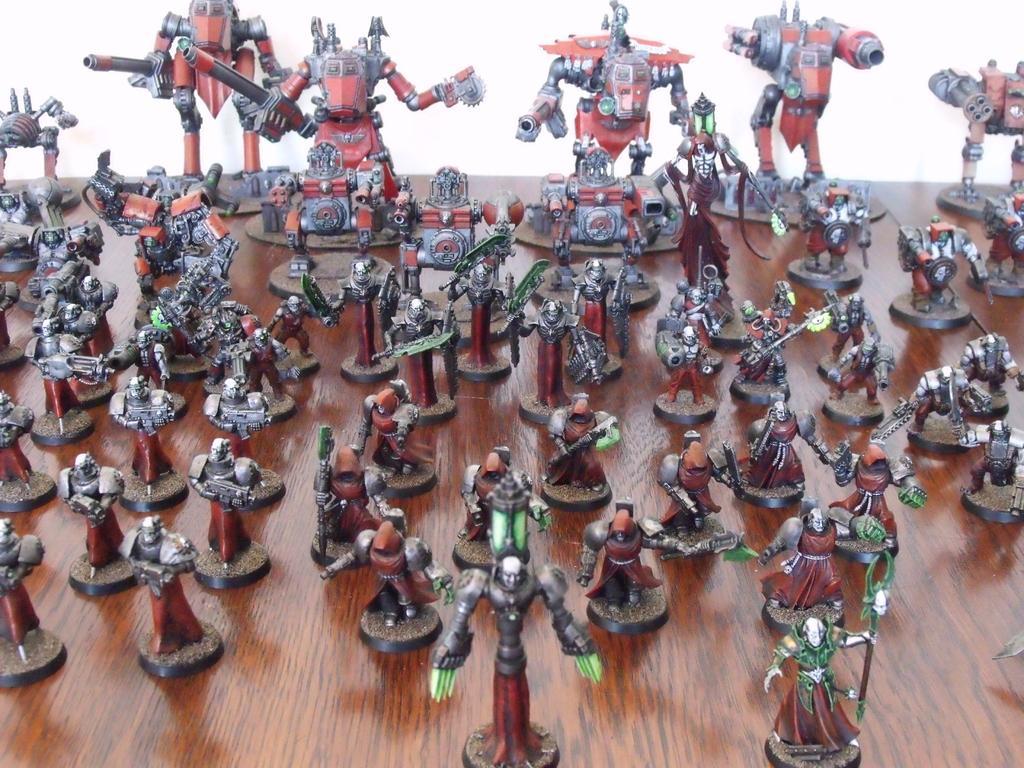In one or two sentences, can you explain what this image depicts? In this picture I can see there is a army of soldiers here and they are wearing red color dress and holding weapons and in the backdrop I can see there are few with special equipments. 